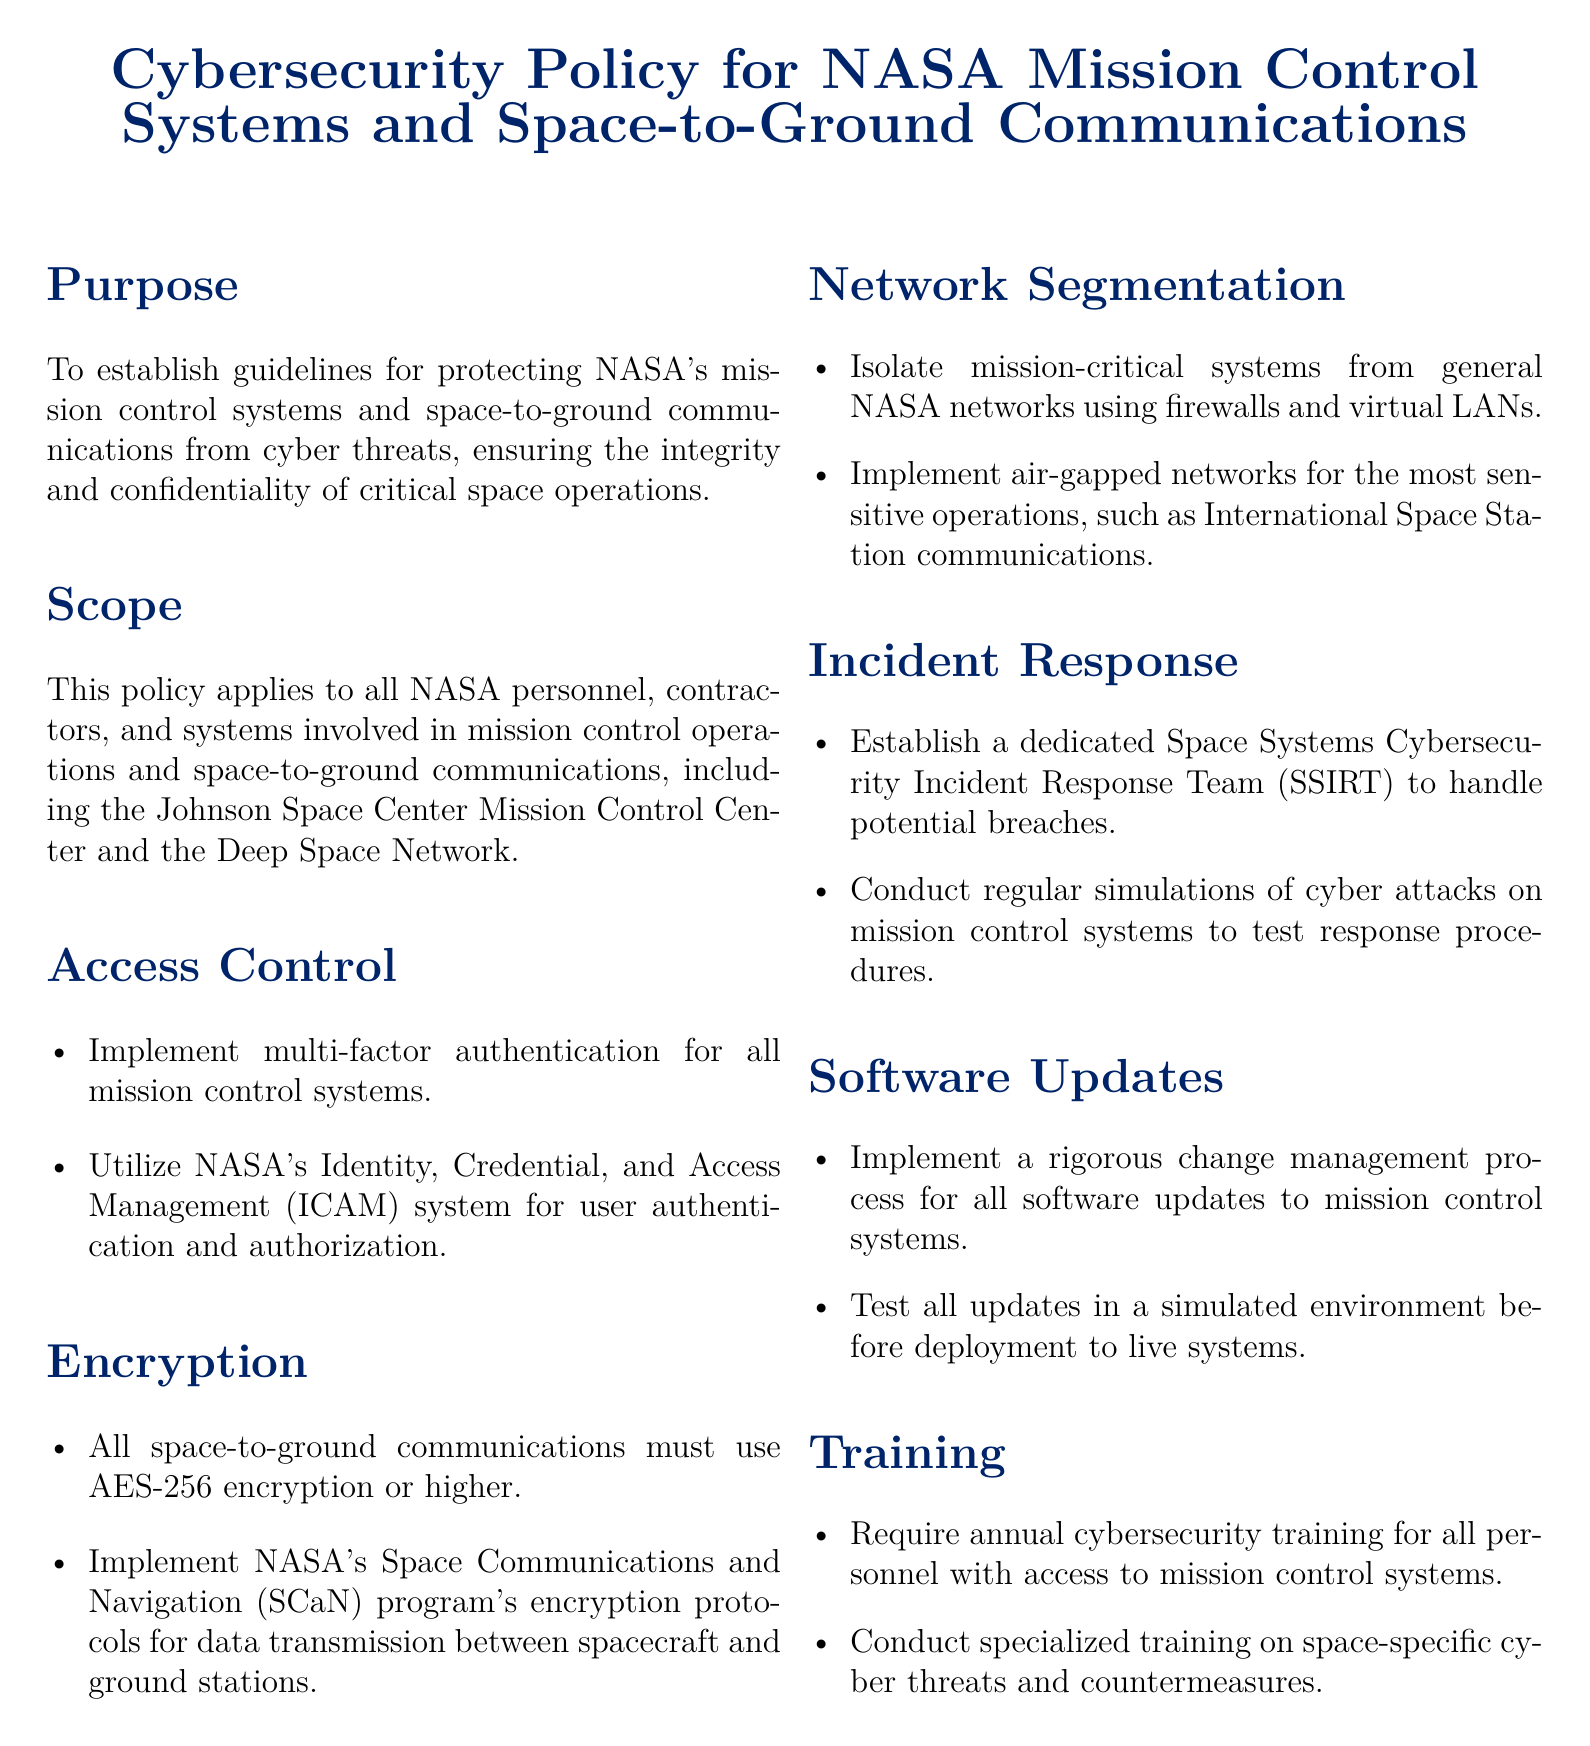What is the purpose of the policy? The purpose is to establish guidelines for protecting NASA's mission control systems and space-to-ground communications from cyber threats.
Answer: Guidelines for protecting NASA's mission control systems and space-to-ground communications What is the encryption standard required for space-to-ground communications? The document states that all space-to-ground communications must use AES-256 encryption or higher.
Answer: AES-256 Who is responsible for user authentication and authorization? NASA's Identity, Credential, and Access Management (ICAM) system is responsible for user authentication and authorization.
Answer: NASA's ICAM system What is the name of the dedicated team for handling cybersecurity incidents? The document mentions the establishment of a Space Systems Cybersecurity Incident Response Team (SSIRT).
Answer: SSIRT How often is annual cybersecurity training required for personnel? The policy requires annual cybersecurity training for all personnel with access to mission control systems.
Answer: Annual What type of network is used for the most sensitive operations? The document mentions implementing air-gapped networks for the most sensitive operations.
Answer: Air-gapped networks What must be tested in a simulated environment before deployment? All software updates to mission control systems must be tested in a simulated environment before deployment.
Answer: Software updates What is included in the access control measures? The policy includes implementing multi-factor authentication for all mission control systems as part of access control measures.
Answer: Multi-factor authentication What does the policy require for network segmentation? The policy requires isolating mission-critical systems from general NASA networks using firewalls and virtual LANs.
Answer: Isolate with firewalls and virtual LANs 